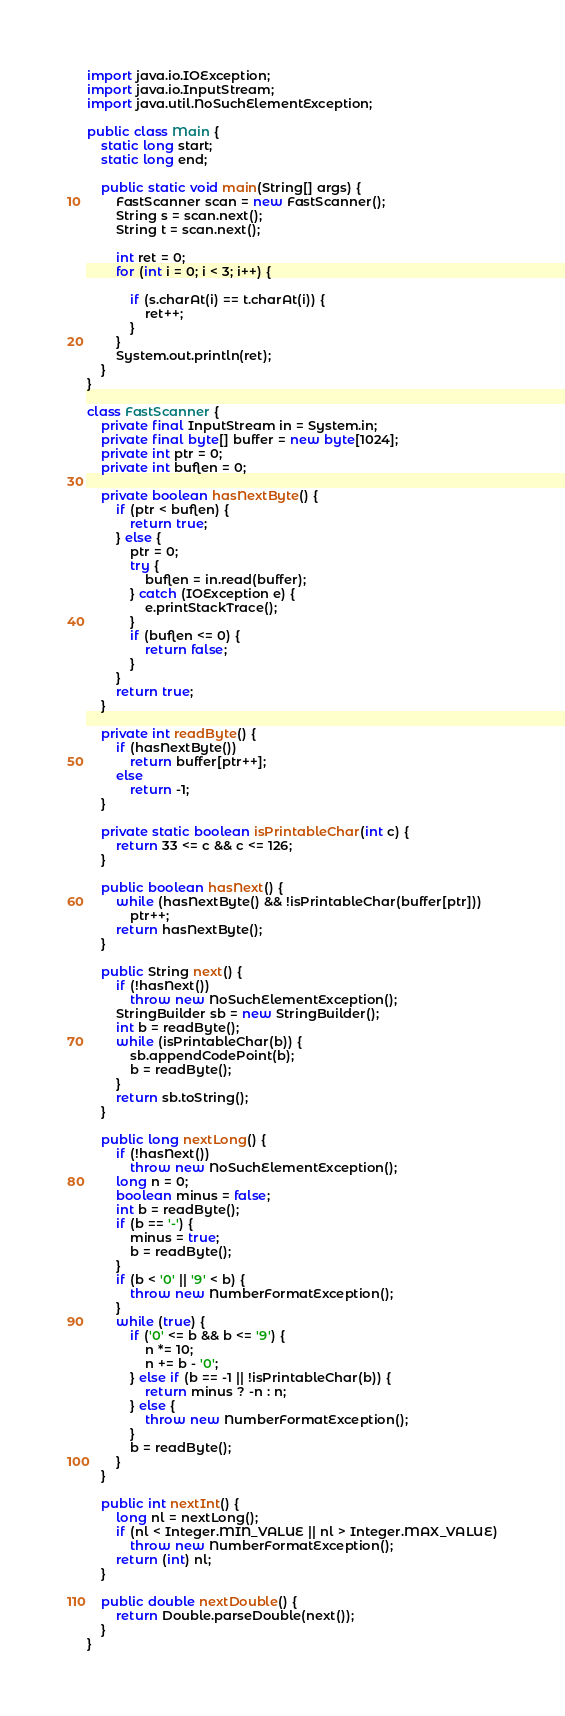<code> <loc_0><loc_0><loc_500><loc_500><_Java_>import java.io.IOException;
import java.io.InputStream;
import java.util.NoSuchElementException;

public class Main {
	static long start;
	static long end;

	public static void main(String[] args) {
		FastScanner scan = new FastScanner();
		String s = scan.next();
		String t = scan.next();

		int ret = 0;
		for (int i = 0; i < 3; i++) {

			if (s.charAt(i) == t.charAt(i)) {
				ret++;
			}
		}
		System.out.println(ret);
	}
}

class FastScanner {
	private final InputStream in = System.in;
	private final byte[] buffer = new byte[1024];
	private int ptr = 0;
	private int buflen = 0;

	private boolean hasNextByte() {
		if (ptr < buflen) {
			return true;
		} else {
			ptr = 0;
			try {
				buflen = in.read(buffer);
			} catch (IOException e) {
				e.printStackTrace();
			}
			if (buflen <= 0) {
				return false;
			}
		}
		return true;
	}

	private int readByte() {
		if (hasNextByte())
			return buffer[ptr++];
		else
			return -1;
	}

	private static boolean isPrintableChar(int c) {
		return 33 <= c && c <= 126;
	}

	public boolean hasNext() {
		while (hasNextByte() && !isPrintableChar(buffer[ptr]))
			ptr++;
		return hasNextByte();
	}

	public String next() {
		if (!hasNext())
			throw new NoSuchElementException();
		StringBuilder sb = new StringBuilder();
		int b = readByte();
		while (isPrintableChar(b)) {
			sb.appendCodePoint(b);
			b = readByte();
		}
		return sb.toString();
	}

	public long nextLong() {
		if (!hasNext())
			throw new NoSuchElementException();
		long n = 0;
		boolean minus = false;
		int b = readByte();
		if (b == '-') {
			minus = true;
			b = readByte();
		}
		if (b < '0' || '9' < b) {
			throw new NumberFormatException();
		}
		while (true) {
			if ('0' <= b && b <= '9') {
				n *= 10;
				n += b - '0';
			} else if (b == -1 || !isPrintableChar(b)) {
				return minus ? -n : n;
			} else {
				throw new NumberFormatException();
			}
			b = readByte();
		}
	}

	public int nextInt() {
		long nl = nextLong();
		if (nl < Integer.MIN_VALUE || nl > Integer.MAX_VALUE)
			throw new NumberFormatException();
		return (int) nl;
	}

	public double nextDouble() {
		return Double.parseDouble(next());
	}
}</code> 